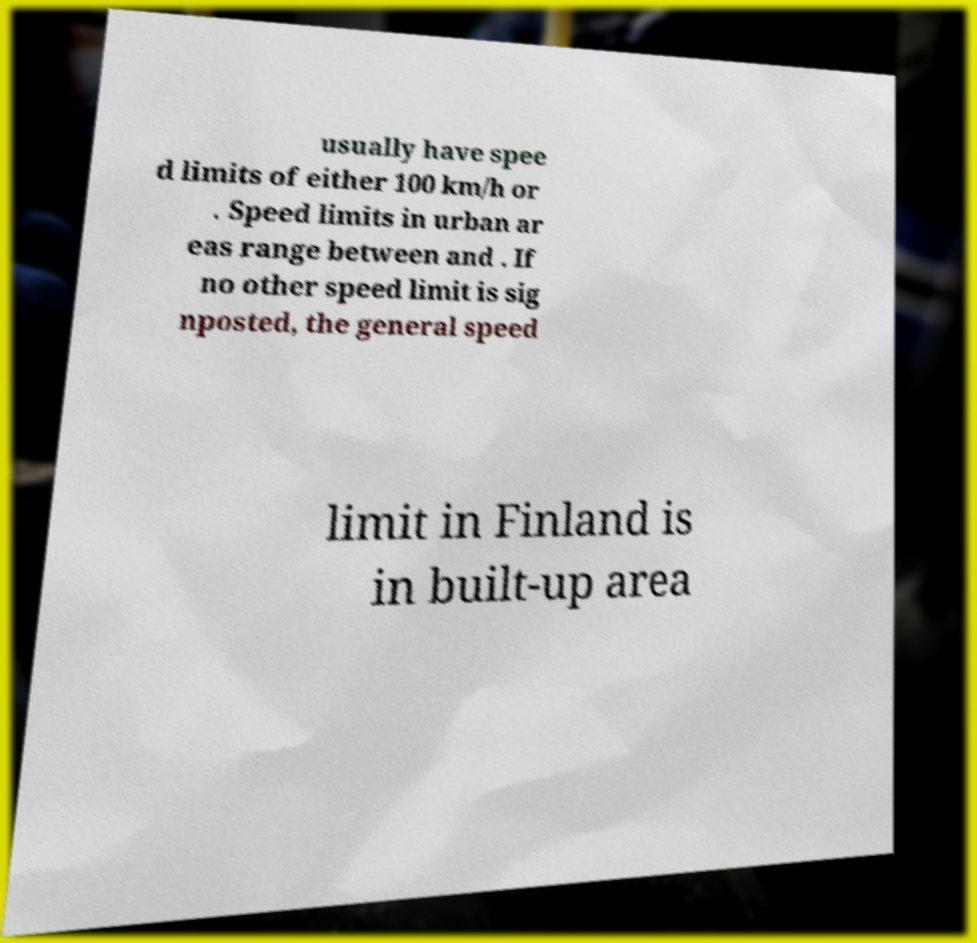Could you extract and type out the text from this image? usually have spee d limits of either 100 km/h or . Speed limits in urban ar eas range between and . If no other speed limit is sig nposted, the general speed limit in Finland is in built-up area 